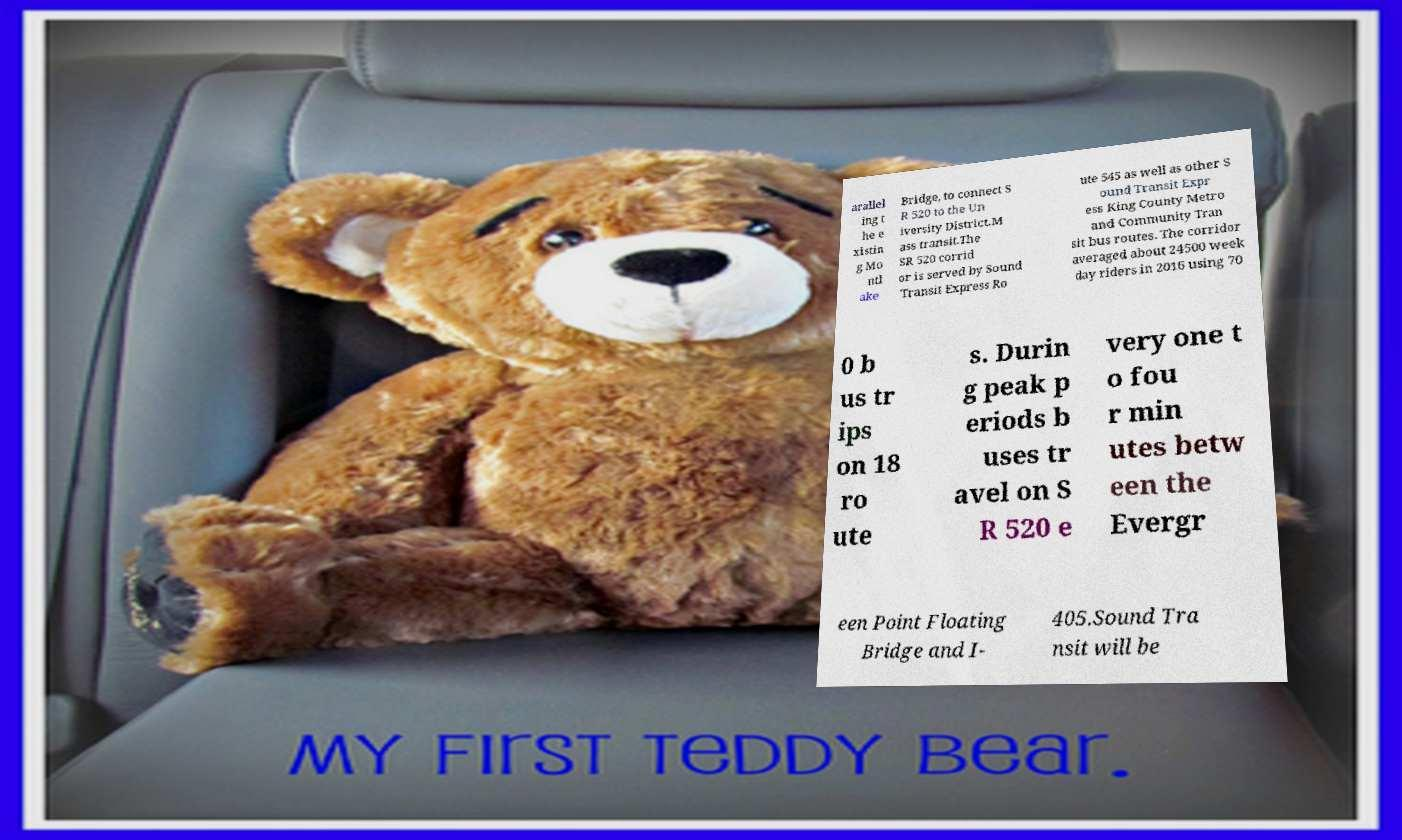Please identify and transcribe the text found in this image. arallel ing t he e xistin g Mo ntl ake Bridge, to connect S R 520 to the Un iversity District.M ass transit.The SR 520 corrid or is served by Sound Transit Express Ro ute 545 as well as other S ound Transit Expr ess King County Metro and Community Tran sit bus routes. The corridor averaged about 24500 week day riders in 2016 using 70 0 b us tr ips on 18 ro ute s. Durin g peak p eriods b uses tr avel on S R 520 e very one t o fou r min utes betw een the Evergr een Point Floating Bridge and I- 405.Sound Tra nsit will be 